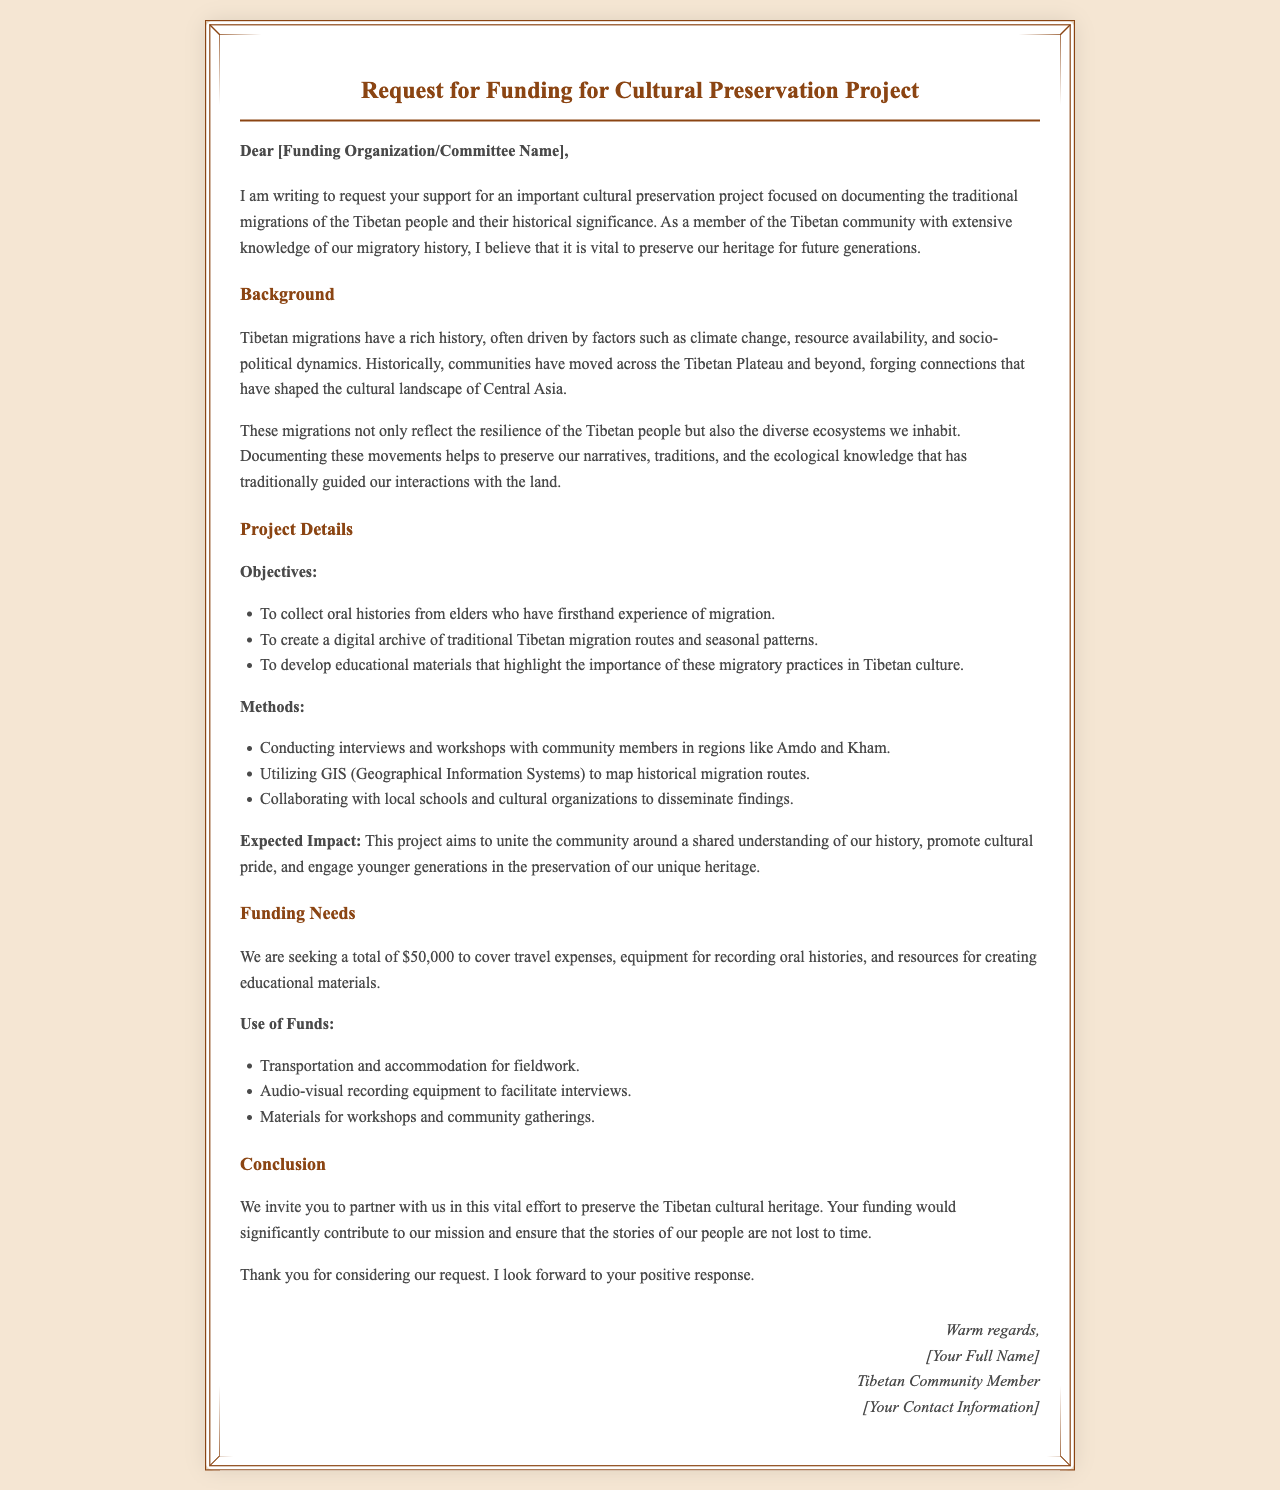What is the total funding requested? The total funding requested is mentioned in the funding needs section of the document.
Answer: $50,000 Who is the intended recipient of the letter? The letter begins with a greeting addressing a specific group, indicating the intended recipient is a funding organization or committee.
Answer: Funding Organization/Committee Name What are the main objectives of the project? The objectives are listed in the project details section and specify what the project aims to achieve.
Answer: Collect oral histories, create a digital archive, develop educational materials What is a method mentioned for documenting migrations? The methods described in the project details section outline various strategies for achieving the objectives.
Answer: Conducting interviews and workshops What is the expected impact of the project? The expected impact is summarized in the project details section, indicating the potential outcomes of the project.
Answer: Unite the community, promote cultural pride, engage younger generations What materials will be recorded for oral histories? The document mentions the type of equipment needed to collect oral histories, suggesting what will be recorded.
Answer: Audio-visual recording equipment How will the funding be used for fieldwork? The use of funds section specifies how the funding will support the logistical aspects of the project.
Answer: Transportation and accommodation What area of Tibet is specifically mentioned for interviews? The document highlights specific regions where community members will be interviewed as part of the project.
Answer: Amdo and Kham What cultural aspect does the project aim to highlight? The document discusses the focus on what specific cultural practices will be preserved through the project.
Answer: Migratory practices 